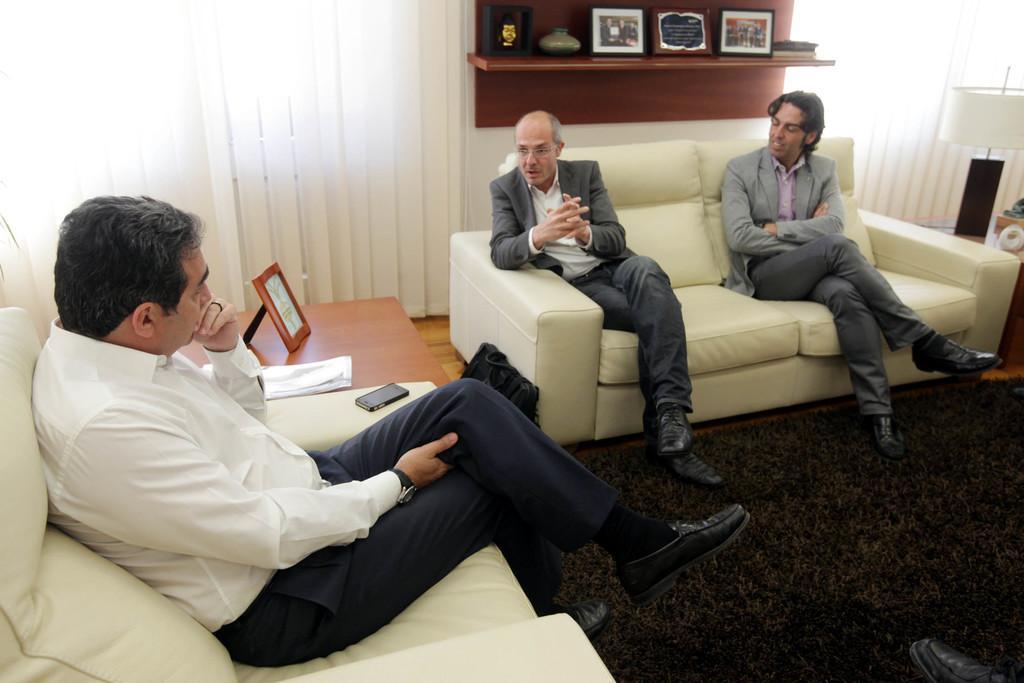Describe this image in one or two sentences. In this image I can see three men are sitting on sofas. In the background I can see table which has some objects on it. On the right side I can see a light lamp. Here I can see a mobile. 